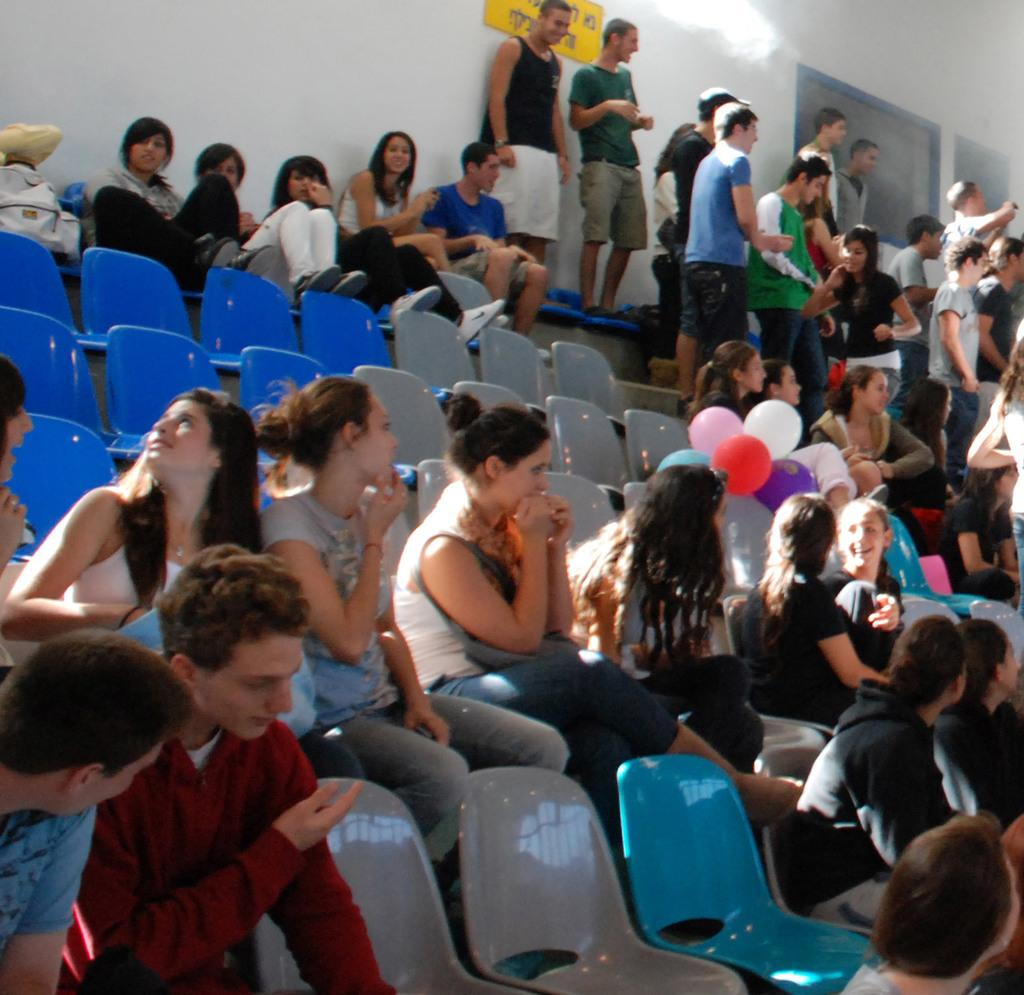What are the people in the image doing? There are people sitting in chairs and people standing in the image. Can you describe the positions of the people in the image? Some people are sitting in chairs, while others are standing. What type of secretary can be seen working in the image? There is no secretary present in the image. How many ducks are visible in the image? There are no ducks present in the image. 